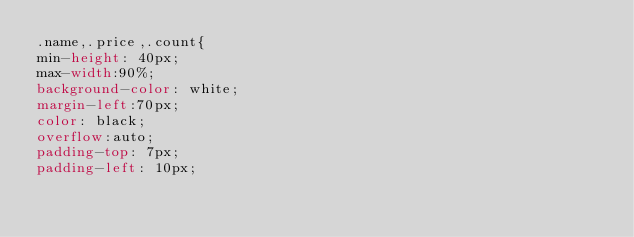Convert code to text. <code><loc_0><loc_0><loc_500><loc_500><_CSS_>.name,.price,.count{
min-height: 40px;
max-width:90%;
background-color: white;
margin-left:70px;
color: black;
overflow:auto;
padding-top: 7px;
padding-left: 10px;</code> 